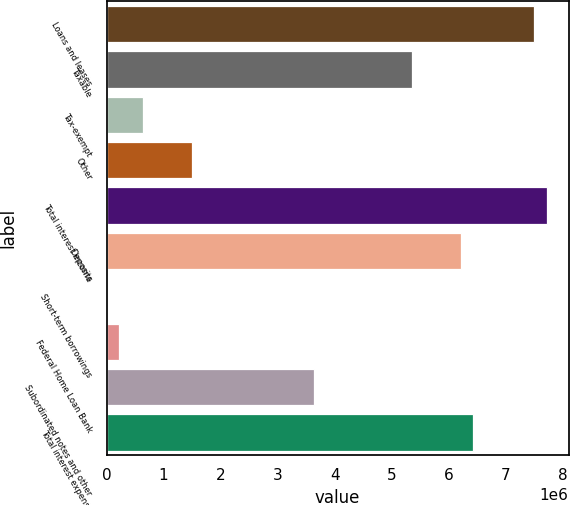Convert chart. <chart><loc_0><loc_0><loc_500><loc_500><bar_chart><fcel>Loans and leases<fcel>Taxable<fcel>Tax-exempt<fcel>Other<fcel>Total interest income<fcel>Deposits<fcel>Short-term borrowings<fcel>Federal Home Loan Bank<fcel>Subordinated notes and other<fcel>Total interest expense<nl><fcel>7.50135e+06<fcel>5.35897e+06<fcel>645722<fcel>1.50268e+06<fcel>7.71559e+06<fcel>6.21592e+06<fcel>3007<fcel>217246<fcel>3.64506e+06<fcel>6.43016e+06<nl></chart> 